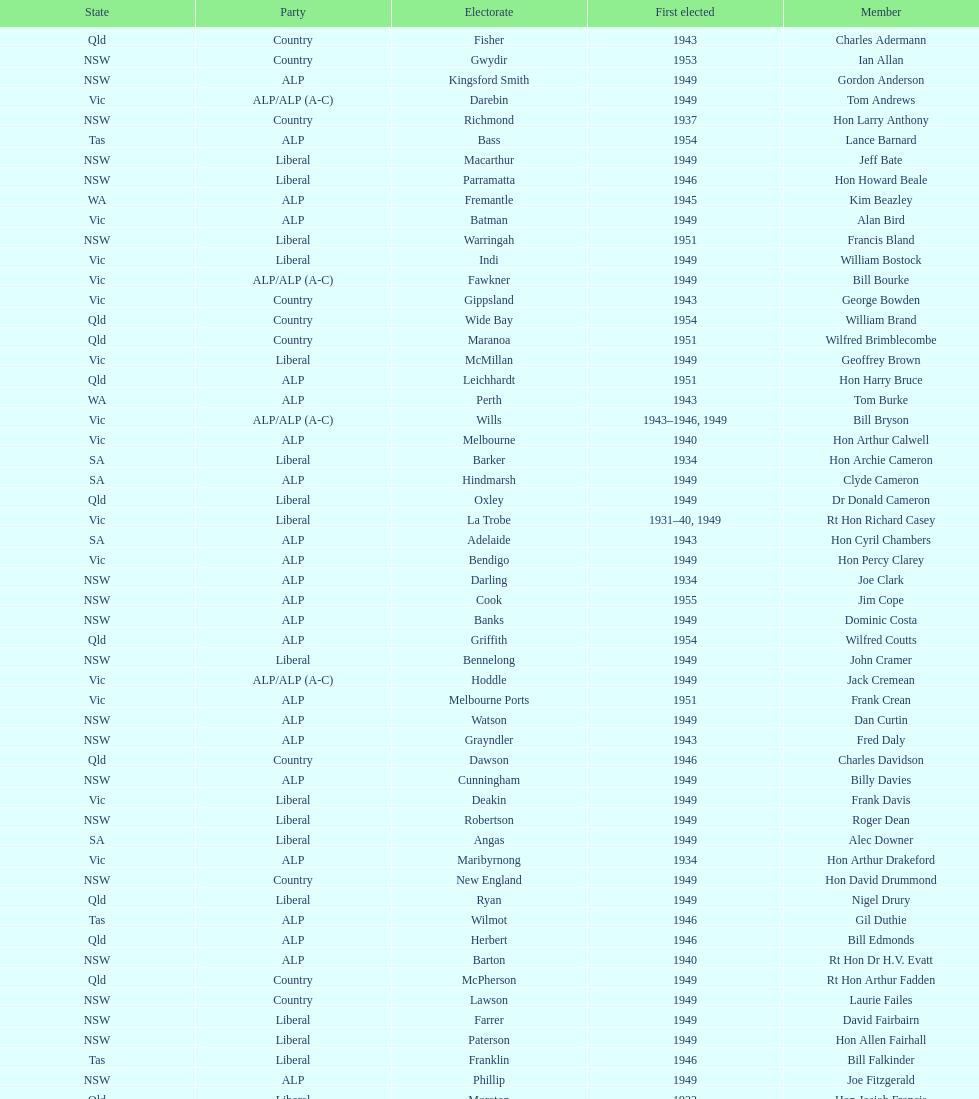Who was the first member to be elected? Charles Adermann. 